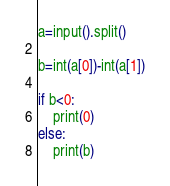Convert code to text. <code><loc_0><loc_0><loc_500><loc_500><_Python_>a=input().split()

b=int(a[0])-int(a[1])

if b<0:
    print(0)
else:
    print(b)</code> 